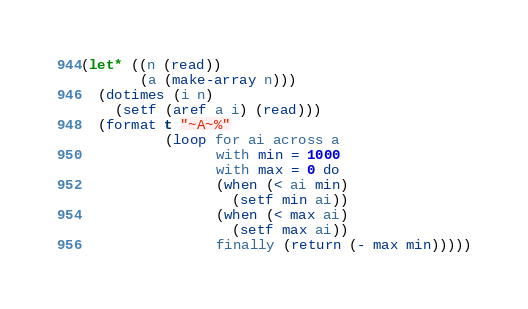Convert code to text. <code><loc_0><loc_0><loc_500><loc_500><_Lisp_>(let* ((n (read))
       (a (make-array n)))
  (dotimes (i n)
    (setf (aref a i) (read)))
  (format t "~A~%"
          (loop for ai across a
                with min = 1000
                with max = 0 do
                (when (< ai min)
                  (setf min ai))
                (when (< max ai)
                  (setf max ai))
                finally (return (- max min)))))</code> 